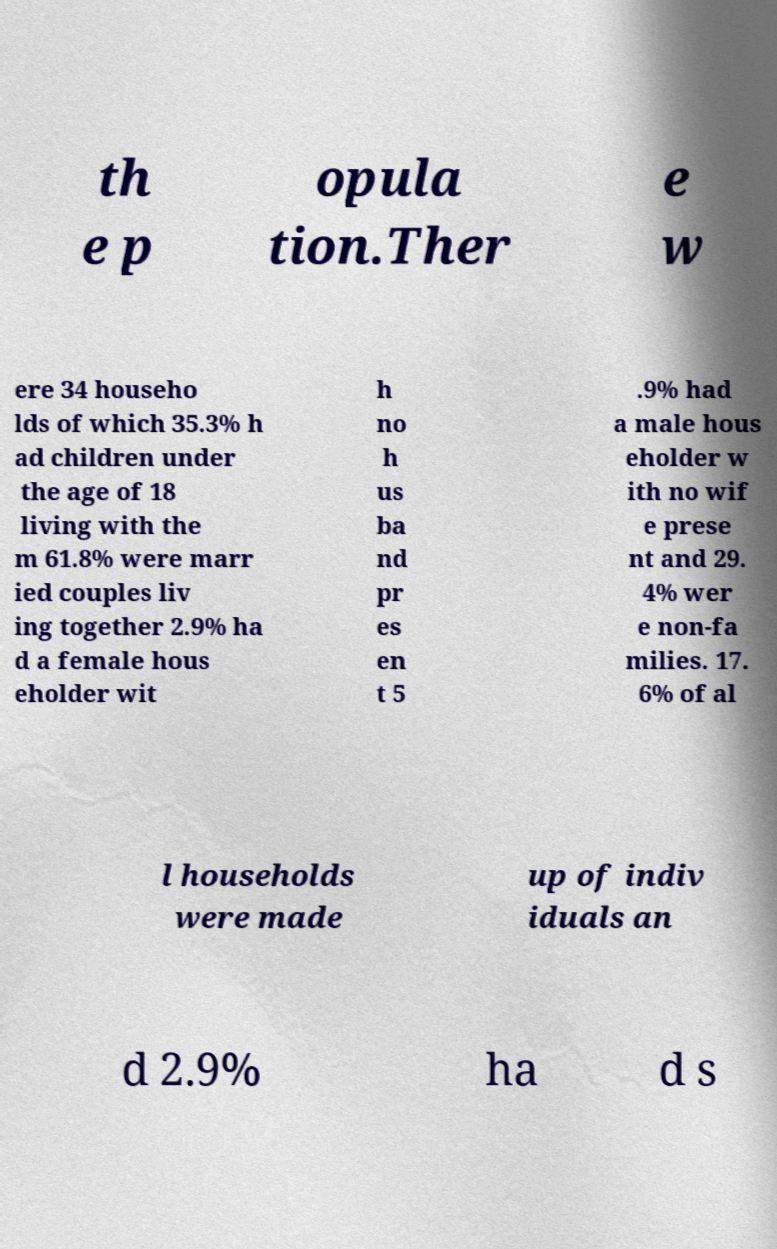Can you accurately transcribe the text from the provided image for me? th e p opula tion.Ther e w ere 34 househo lds of which 35.3% h ad children under the age of 18 living with the m 61.8% were marr ied couples liv ing together 2.9% ha d a female hous eholder wit h no h us ba nd pr es en t 5 .9% had a male hous eholder w ith no wif e prese nt and 29. 4% wer e non-fa milies. 17. 6% of al l households were made up of indiv iduals an d 2.9% ha d s 